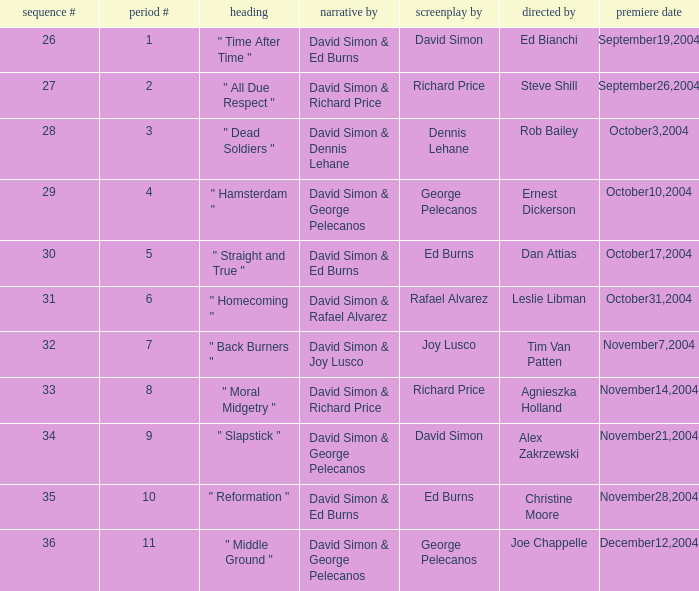Would you mind parsing the complete table? {'header': ['sequence #', 'period #', 'heading', 'narrative by', 'screenplay by', 'directed by', 'premiere date'], 'rows': [['26', '1', '" Time After Time "', 'David Simon & Ed Burns', 'David Simon', 'Ed Bianchi', 'September19,2004'], ['27', '2', '" All Due Respect "', 'David Simon & Richard Price', 'Richard Price', 'Steve Shill', 'September26,2004'], ['28', '3', '" Dead Soldiers "', 'David Simon & Dennis Lehane', 'Dennis Lehane', 'Rob Bailey', 'October3,2004'], ['29', '4', '" Hamsterdam "', 'David Simon & George Pelecanos', 'George Pelecanos', 'Ernest Dickerson', 'October10,2004'], ['30', '5', '" Straight and True "', 'David Simon & Ed Burns', 'Ed Burns', 'Dan Attias', 'October17,2004'], ['31', '6', '" Homecoming "', 'David Simon & Rafael Alvarez', 'Rafael Alvarez', 'Leslie Libman', 'October31,2004'], ['32', '7', '" Back Burners "', 'David Simon & Joy Lusco', 'Joy Lusco', 'Tim Van Patten', 'November7,2004'], ['33', '8', '" Moral Midgetry "', 'David Simon & Richard Price', 'Richard Price', 'Agnieszka Holland', 'November14,2004'], ['34', '9', '" Slapstick "', 'David Simon & George Pelecanos', 'David Simon', 'Alex Zakrzewski', 'November21,2004'], ['35', '10', '" Reformation "', 'David Simon & Ed Burns', 'Ed Burns', 'Christine Moore', 'November28,2004'], ['36', '11', '" Middle Ground "', 'David Simon & George Pelecanos', 'George Pelecanos', 'Joe Chappelle', 'December12,2004']]} What is the total number of values for "Teleplay by" category for series # 35? 1.0. 